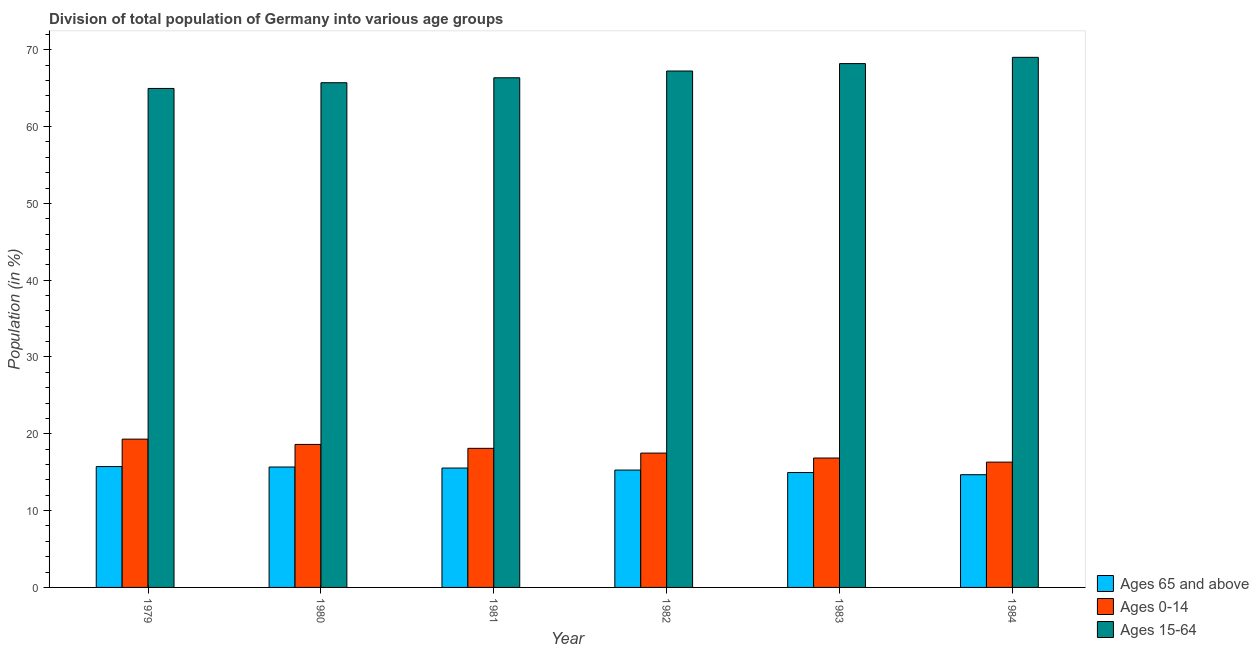Are the number of bars per tick equal to the number of legend labels?
Give a very brief answer. Yes. Are the number of bars on each tick of the X-axis equal?
Your answer should be compact. Yes. How many bars are there on the 6th tick from the right?
Provide a short and direct response. 3. What is the label of the 4th group of bars from the left?
Your answer should be compact. 1982. What is the percentage of population within the age-group 0-14 in 1982?
Make the answer very short. 17.49. Across all years, what is the maximum percentage of population within the age-group 15-64?
Provide a succinct answer. 69.01. Across all years, what is the minimum percentage of population within the age-group of 65 and above?
Your answer should be very brief. 14.67. In which year was the percentage of population within the age-group 15-64 minimum?
Your answer should be compact. 1979. What is the total percentage of population within the age-group 0-14 in the graph?
Provide a short and direct response. 106.68. What is the difference between the percentage of population within the age-group of 65 and above in 1981 and that in 1983?
Ensure brevity in your answer.  0.59. What is the difference between the percentage of population within the age-group 0-14 in 1982 and the percentage of population within the age-group of 65 and above in 1981?
Your response must be concise. -0.62. What is the average percentage of population within the age-group of 65 and above per year?
Your answer should be compact. 15.31. What is the ratio of the percentage of population within the age-group 15-64 in 1979 to that in 1982?
Offer a very short reply. 0.97. Is the difference between the percentage of population within the age-group 15-64 in 1981 and 1984 greater than the difference between the percentage of population within the age-group of 65 and above in 1981 and 1984?
Give a very brief answer. No. What is the difference between the highest and the second highest percentage of population within the age-group of 65 and above?
Keep it short and to the point. 0.06. What is the difference between the highest and the lowest percentage of population within the age-group 0-14?
Offer a very short reply. 2.99. In how many years, is the percentage of population within the age-group 15-64 greater than the average percentage of population within the age-group 15-64 taken over all years?
Ensure brevity in your answer.  3. Is the sum of the percentage of population within the age-group 0-14 in 1980 and 1982 greater than the maximum percentage of population within the age-group 15-64 across all years?
Keep it short and to the point. Yes. What does the 2nd bar from the left in 1980 represents?
Offer a very short reply. Ages 0-14. What does the 3rd bar from the right in 1983 represents?
Give a very brief answer. Ages 65 and above. Are all the bars in the graph horizontal?
Provide a short and direct response. No. How many years are there in the graph?
Offer a very short reply. 6. What is the difference between two consecutive major ticks on the Y-axis?
Offer a very short reply. 10. Are the values on the major ticks of Y-axis written in scientific E-notation?
Offer a very short reply. No. Does the graph contain grids?
Make the answer very short. No. How many legend labels are there?
Ensure brevity in your answer.  3. What is the title of the graph?
Give a very brief answer. Division of total population of Germany into various age groups
. Does "Transport equipments" appear as one of the legend labels in the graph?
Provide a short and direct response. No. What is the label or title of the X-axis?
Make the answer very short. Year. What is the Population (in %) of Ages 65 and above in 1979?
Give a very brief answer. 15.73. What is the Population (in %) in Ages 0-14 in 1979?
Your response must be concise. 19.31. What is the Population (in %) in Ages 15-64 in 1979?
Offer a terse response. 64.96. What is the Population (in %) in Ages 65 and above in 1980?
Offer a very short reply. 15.68. What is the Population (in %) of Ages 0-14 in 1980?
Make the answer very short. 18.62. What is the Population (in %) in Ages 15-64 in 1980?
Offer a terse response. 65.71. What is the Population (in %) in Ages 65 and above in 1981?
Make the answer very short. 15.54. What is the Population (in %) in Ages 0-14 in 1981?
Your response must be concise. 18.11. What is the Population (in %) in Ages 15-64 in 1981?
Offer a very short reply. 66.35. What is the Population (in %) in Ages 65 and above in 1982?
Offer a very short reply. 15.28. What is the Population (in %) of Ages 0-14 in 1982?
Offer a very short reply. 17.49. What is the Population (in %) in Ages 15-64 in 1982?
Offer a terse response. 67.23. What is the Population (in %) of Ages 65 and above in 1983?
Keep it short and to the point. 14.96. What is the Population (in %) in Ages 0-14 in 1983?
Your answer should be compact. 16.85. What is the Population (in %) in Ages 15-64 in 1983?
Give a very brief answer. 68.2. What is the Population (in %) of Ages 65 and above in 1984?
Make the answer very short. 14.67. What is the Population (in %) in Ages 0-14 in 1984?
Give a very brief answer. 16.31. What is the Population (in %) of Ages 15-64 in 1984?
Your answer should be very brief. 69.01. Across all years, what is the maximum Population (in %) of Ages 65 and above?
Give a very brief answer. 15.73. Across all years, what is the maximum Population (in %) in Ages 0-14?
Ensure brevity in your answer.  19.31. Across all years, what is the maximum Population (in %) in Ages 15-64?
Keep it short and to the point. 69.01. Across all years, what is the minimum Population (in %) of Ages 65 and above?
Give a very brief answer. 14.67. Across all years, what is the minimum Population (in %) in Ages 0-14?
Provide a short and direct response. 16.31. Across all years, what is the minimum Population (in %) of Ages 15-64?
Provide a succinct answer. 64.96. What is the total Population (in %) of Ages 65 and above in the graph?
Give a very brief answer. 91.86. What is the total Population (in %) of Ages 0-14 in the graph?
Keep it short and to the point. 106.68. What is the total Population (in %) of Ages 15-64 in the graph?
Provide a succinct answer. 401.46. What is the difference between the Population (in %) in Ages 65 and above in 1979 and that in 1980?
Offer a very short reply. 0.06. What is the difference between the Population (in %) in Ages 0-14 in 1979 and that in 1980?
Provide a succinct answer. 0.69. What is the difference between the Population (in %) of Ages 15-64 in 1979 and that in 1980?
Make the answer very short. -0.75. What is the difference between the Population (in %) in Ages 65 and above in 1979 and that in 1981?
Your response must be concise. 0.19. What is the difference between the Population (in %) in Ages 0-14 in 1979 and that in 1981?
Ensure brevity in your answer.  1.2. What is the difference between the Population (in %) of Ages 15-64 in 1979 and that in 1981?
Offer a terse response. -1.39. What is the difference between the Population (in %) of Ages 65 and above in 1979 and that in 1982?
Ensure brevity in your answer.  0.45. What is the difference between the Population (in %) of Ages 0-14 in 1979 and that in 1982?
Keep it short and to the point. 1.82. What is the difference between the Population (in %) in Ages 15-64 in 1979 and that in 1982?
Your response must be concise. -2.27. What is the difference between the Population (in %) of Ages 65 and above in 1979 and that in 1983?
Offer a terse response. 0.78. What is the difference between the Population (in %) of Ages 0-14 in 1979 and that in 1983?
Keep it short and to the point. 2.46. What is the difference between the Population (in %) in Ages 15-64 in 1979 and that in 1983?
Offer a terse response. -3.24. What is the difference between the Population (in %) in Ages 65 and above in 1979 and that in 1984?
Ensure brevity in your answer.  1.06. What is the difference between the Population (in %) in Ages 0-14 in 1979 and that in 1984?
Ensure brevity in your answer.  2.99. What is the difference between the Population (in %) in Ages 15-64 in 1979 and that in 1984?
Provide a short and direct response. -4.05. What is the difference between the Population (in %) in Ages 65 and above in 1980 and that in 1981?
Ensure brevity in your answer.  0.14. What is the difference between the Population (in %) of Ages 0-14 in 1980 and that in 1981?
Give a very brief answer. 0.51. What is the difference between the Population (in %) in Ages 15-64 in 1980 and that in 1981?
Provide a succinct answer. -0.64. What is the difference between the Population (in %) of Ages 65 and above in 1980 and that in 1982?
Provide a succinct answer. 0.4. What is the difference between the Population (in %) of Ages 0-14 in 1980 and that in 1982?
Make the answer very short. 1.13. What is the difference between the Population (in %) of Ages 15-64 in 1980 and that in 1982?
Give a very brief answer. -1.52. What is the difference between the Population (in %) in Ages 65 and above in 1980 and that in 1983?
Provide a short and direct response. 0.72. What is the difference between the Population (in %) of Ages 0-14 in 1980 and that in 1983?
Provide a short and direct response. 1.77. What is the difference between the Population (in %) of Ages 15-64 in 1980 and that in 1983?
Give a very brief answer. -2.49. What is the difference between the Population (in %) in Ages 0-14 in 1980 and that in 1984?
Give a very brief answer. 2.3. What is the difference between the Population (in %) in Ages 15-64 in 1980 and that in 1984?
Offer a very short reply. -3.31. What is the difference between the Population (in %) of Ages 65 and above in 1981 and that in 1982?
Ensure brevity in your answer.  0.26. What is the difference between the Population (in %) in Ages 0-14 in 1981 and that in 1982?
Offer a terse response. 0.62. What is the difference between the Population (in %) of Ages 15-64 in 1981 and that in 1982?
Make the answer very short. -0.88. What is the difference between the Population (in %) of Ages 65 and above in 1981 and that in 1983?
Provide a succinct answer. 0.59. What is the difference between the Population (in %) of Ages 0-14 in 1981 and that in 1983?
Your response must be concise. 1.26. What is the difference between the Population (in %) in Ages 15-64 in 1981 and that in 1983?
Your response must be concise. -1.85. What is the difference between the Population (in %) in Ages 65 and above in 1981 and that in 1984?
Your response must be concise. 0.87. What is the difference between the Population (in %) of Ages 0-14 in 1981 and that in 1984?
Provide a short and direct response. 1.79. What is the difference between the Population (in %) in Ages 15-64 in 1981 and that in 1984?
Provide a short and direct response. -2.66. What is the difference between the Population (in %) in Ages 65 and above in 1982 and that in 1983?
Ensure brevity in your answer.  0.32. What is the difference between the Population (in %) of Ages 0-14 in 1982 and that in 1983?
Provide a short and direct response. 0.64. What is the difference between the Population (in %) in Ages 15-64 in 1982 and that in 1983?
Make the answer very short. -0.97. What is the difference between the Population (in %) in Ages 65 and above in 1982 and that in 1984?
Offer a terse response. 0.6. What is the difference between the Population (in %) of Ages 0-14 in 1982 and that in 1984?
Ensure brevity in your answer.  1.18. What is the difference between the Population (in %) in Ages 15-64 in 1982 and that in 1984?
Offer a terse response. -1.78. What is the difference between the Population (in %) in Ages 65 and above in 1983 and that in 1984?
Provide a short and direct response. 0.28. What is the difference between the Population (in %) in Ages 0-14 in 1983 and that in 1984?
Offer a very short reply. 0.53. What is the difference between the Population (in %) in Ages 15-64 in 1983 and that in 1984?
Your answer should be very brief. -0.82. What is the difference between the Population (in %) in Ages 65 and above in 1979 and the Population (in %) in Ages 0-14 in 1980?
Give a very brief answer. -2.88. What is the difference between the Population (in %) in Ages 65 and above in 1979 and the Population (in %) in Ages 15-64 in 1980?
Your answer should be compact. -49.97. What is the difference between the Population (in %) in Ages 0-14 in 1979 and the Population (in %) in Ages 15-64 in 1980?
Give a very brief answer. -46.4. What is the difference between the Population (in %) of Ages 65 and above in 1979 and the Population (in %) of Ages 0-14 in 1981?
Ensure brevity in your answer.  -2.37. What is the difference between the Population (in %) in Ages 65 and above in 1979 and the Population (in %) in Ages 15-64 in 1981?
Your response must be concise. -50.62. What is the difference between the Population (in %) in Ages 0-14 in 1979 and the Population (in %) in Ages 15-64 in 1981?
Your answer should be compact. -47.04. What is the difference between the Population (in %) in Ages 65 and above in 1979 and the Population (in %) in Ages 0-14 in 1982?
Provide a short and direct response. -1.76. What is the difference between the Population (in %) of Ages 65 and above in 1979 and the Population (in %) of Ages 15-64 in 1982?
Offer a very short reply. -51.5. What is the difference between the Population (in %) of Ages 0-14 in 1979 and the Population (in %) of Ages 15-64 in 1982?
Keep it short and to the point. -47.93. What is the difference between the Population (in %) of Ages 65 and above in 1979 and the Population (in %) of Ages 0-14 in 1983?
Offer a terse response. -1.11. What is the difference between the Population (in %) in Ages 65 and above in 1979 and the Population (in %) in Ages 15-64 in 1983?
Keep it short and to the point. -52.46. What is the difference between the Population (in %) of Ages 0-14 in 1979 and the Population (in %) of Ages 15-64 in 1983?
Your response must be concise. -48.89. What is the difference between the Population (in %) in Ages 65 and above in 1979 and the Population (in %) in Ages 0-14 in 1984?
Provide a succinct answer. -0.58. What is the difference between the Population (in %) in Ages 65 and above in 1979 and the Population (in %) in Ages 15-64 in 1984?
Give a very brief answer. -53.28. What is the difference between the Population (in %) of Ages 0-14 in 1979 and the Population (in %) of Ages 15-64 in 1984?
Keep it short and to the point. -49.71. What is the difference between the Population (in %) of Ages 65 and above in 1980 and the Population (in %) of Ages 0-14 in 1981?
Keep it short and to the point. -2.43. What is the difference between the Population (in %) in Ages 65 and above in 1980 and the Population (in %) in Ages 15-64 in 1981?
Make the answer very short. -50.67. What is the difference between the Population (in %) in Ages 0-14 in 1980 and the Population (in %) in Ages 15-64 in 1981?
Offer a very short reply. -47.73. What is the difference between the Population (in %) in Ages 65 and above in 1980 and the Population (in %) in Ages 0-14 in 1982?
Give a very brief answer. -1.81. What is the difference between the Population (in %) of Ages 65 and above in 1980 and the Population (in %) of Ages 15-64 in 1982?
Offer a very short reply. -51.55. What is the difference between the Population (in %) of Ages 0-14 in 1980 and the Population (in %) of Ages 15-64 in 1982?
Offer a terse response. -48.61. What is the difference between the Population (in %) of Ages 65 and above in 1980 and the Population (in %) of Ages 0-14 in 1983?
Your answer should be very brief. -1.17. What is the difference between the Population (in %) in Ages 65 and above in 1980 and the Population (in %) in Ages 15-64 in 1983?
Keep it short and to the point. -52.52. What is the difference between the Population (in %) of Ages 0-14 in 1980 and the Population (in %) of Ages 15-64 in 1983?
Provide a short and direct response. -49.58. What is the difference between the Population (in %) in Ages 65 and above in 1980 and the Population (in %) in Ages 0-14 in 1984?
Your answer should be very brief. -0.64. What is the difference between the Population (in %) in Ages 65 and above in 1980 and the Population (in %) in Ages 15-64 in 1984?
Your response must be concise. -53.33. What is the difference between the Population (in %) of Ages 0-14 in 1980 and the Population (in %) of Ages 15-64 in 1984?
Ensure brevity in your answer.  -50.4. What is the difference between the Population (in %) of Ages 65 and above in 1981 and the Population (in %) of Ages 0-14 in 1982?
Ensure brevity in your answer.  -1.95. What is the difference between the Population (in %) of Ages 65 and above in 1981 and the Population (in %) of Ages 15-64 in 1982?
Give a very brief answer. -51.69. What is the difference between the Population (in %) in Ages 0-14 in 1981 and the Population (in %) in Ages 15-64 in 1982?
Offer a very short reply. -49.12. What is the difference between the Population (in %) of Ages 65 and above in 1981 and the Population (in %) of Ages 0-14 in 1983?
Your answer should be very brief. -1.31. What is the difference between the Population (in %) in Ages 65 and above in 1981 and the Population (in %) in Ages 15-64 in 1983?
Your response must be concise. -52.65. What is the difference between the Population (in %) of Ages 0-14 in 1981 and the Population (in %) of Ages 15-64 in 1983?
Provide a short and direct response. -50.09. What is the difference between the Population (in %) of Ages 65 and above in 1981 and the Population (in %) of Ages 0-14 in 1984?
Ensure brevity in your answer.  -0.77. What is the difference between the Population (in %) of Ages 65 and above in 1981 and the Population (in %) of Ages 15-64 in 1984?
Your response must be concise. -53.47. What is the difference between the Population (in %) in Ages 0-14 in 1981 and the Population (in %) in Ages 15-64 in 1984?
Offer a terse response. -50.9. What is the difference between the Population (in %) in Ages 65 and above in 1982 and the Population (in %) in Ages 0-14 in 1983?
Offer a terse response. -1.57. What is the difference between the Population (in %) of Ages 65 and above in 1982 and the Population (in %) of Ages 15-64 in 1983?
Provide a short and direct response. -52.92. What is the difference between the Population (in %) of Ages 0-14 in 1982 and the Population (in %) of Ages 15-64 in 1983?
Keep it short and to the point. -50.71. What is the difference between the Population (in %) in Ages 65 and above in 1982 and the Population (in %) in Ages 0-14 in 1984?
Your response must be concise. -1.03. What is the difference between the Population (in %) in Ages 65 and above in 1982 and the Population (in %) in Ages 15-64 in 1984?
Provide a short and direct response. -53.73. What is the difference between the Population (in %) of Ages 0-14 in 1982 and the Population (in %) of Ages 15-64 in 1984?
Give a very brief answer. -51.52. What is the difference between the Population (in %) in Ages 65 and above in 1983 and the Population (in %) in Ages 0-14 in 1984?
Offer a very short reply. -1.36. What is the difference between the Population (in %) of Ages 65 and above in 1983 and the Population (in %) of Ages 15-64 in 1984?
Provide a short and direct response. -54.05. What is the difference between the Population (in %) in Ages 0-14 in 1983 and the Population (in %) in Ages 15-64 in 1984?
Offer a very short reply. -52.16. What is the average Population (in %) in Ages 65 and above per year?
Provide a short and direct response. 15.31. What is the average Population (in %) of Ages 0-14 per year?
Ensure brevity in your answer.  17.78. What is the average Population (in %) of Ages 15-64 per year?
Provide a succinct answer. 66.91. In the year 1979, what is the difference between the Population (in %) in Ages 65 and above and Population (in %) in Ages 0-14?
Your response must be concise. -3.57. In the year 1979, what is the difference between the Population (in %) in Ages 65 and above and Population (in %) in Ages 15-64?
Your response must be concise. -49.23. In the year 1979, what is the difference between the Population (in %) of Ages 0-14 and Population (in %) of Ages 15-64?
Give a very brief answer. -45.66. In the year 1980, what is the difference between the Population (in %) of Ages 65 and above and Population (in %) of Ages 0-14?
Your response must be concise. -2.94. In the year 1980, what is the difference between the Population (in %) of Ages 65 and above and Population (in %) of Ages 15-64?
Give a very brief answer. -50.03. In the year 1980, what is the difference between the Population (in %) of Ages 0-14 and Population (in %) of Ages 15-64?
Give a very brief answer. -47.09. In the year 1981, what is the difference between the Population (in %) of Ages 65 and above and Population (in %) of Ages 0-14?
Keep it short and to the point. -2.57. In the year 1981, what is the difference between the Population (in %) in Ages 65 and above and Population (in %) in Ages 15-64?
Ensure brevity in your answer.  -50.81. In the year 1981, what is the difference between the Population (in %) of Ages 0-14 and Population (in %) of Ages 15-64?
Ensure brevity in your answer.  -48.24. In the year 1982, what is the difference between the Population (in %) of Ages 65 and above and Population (in %) of Ages 0-14?
Your answer should be very brief. -2.21. In the year 1982, what is the difference between the Population (in %) in Ages 65 and above and Population (in %) in Ages 15-64?
Give a very brief answer. -51.95. In the year 1982, what is the difference between the Population (in %) in Ages 0-14 and Population (in %) in Ages 15-64?
Your answer should be very brief. -49.74. In the year 1983, what is the difference between the Population (in %) of Ages 65 and above and Population (in %) of Ages 0-14?
Offer a terse response. -1.89. In the year 1983, what is the difference between the Population (in %) of Ages 65 and above and Population (in %) of Ages 15-64?
Make the answer very short. -53.24. In the year 1983, what is the difference between the Population (in %) of Ages 0-14 and Population (in %) of Ages 15-64?
Offer a terse response. -51.35. In the year 1984, what is the difference between the Population (in %) of Ages 65 and above and Population (in %) of Ages 0-14?
Provide a succinct answer. -1.64. In the year 1984, what is the difference between the Population (in %) in Ages 65 and above and Population (in %) in Ages 15-64?
Offer a terse response. -54.34. In the year 1984, what is the difference between the Population (in %) of Ages 0-14 and Population (in %) of Ages 15-64?
Offer a very short reply. -52.7. What is the ratio of the Population (in %) in Ages 65 and above in 1979 to that in 1980?
Provide a succinct answer. 1. What is the ratio of the Population (in %) in Ages 15-64 in 1979 to that in 1980?
Offer a very short reply. 0.99. What is the ratio of the Population (in %) in Ages 65 and above in 1979 to that in 1981?
Provide a short and direct response. 1.01. What is the ratio of the Population (in %) of Ages 0-14 in 1979 to that in 1981?
Offer a very short reply. 1.07. What is the ratio of the Population (in %) of Ages 15-64 in 1979 to that in 1981?
Keep it short and to the point. 0.98. What is the ratio of the Population (in %) of Ages 65 and above in 1979 to that in 1982?
Offer a very short reply. 1.03. What is the ratio of the Population (in %) in Ages 0-14 in 1979 to that in 1982?
Offer a terse response. 1.1. What is the ratio of the Population (in %) in Ages 15-64 in 1979 to that in 1982?
Your answer should be compact. 0.97. What is the ratio of the Population (in %) in Ages 65 and above in 1979 to that in 1983?
Your answer should be compact. 1.05. What is the ratio of the Population (in %) in Ages 0-14 in 1979 to that in 1983?
Make the answer very short. 1.15. What is the ratio of the Population (in %) of Ages 15-64 in 1979 to that in 1983?
Your response must be concise. 0.95. What is the ratio of the Population (in %) in Ages 65 and above in 1979 to that in 1984?
Your answer should be very brief. 1.07. What is the ratio of the Population (in %) of Ages 0-14 in 1979 to that in 1984?
Give a very brief answer. 1.18. What is the ratio of the Population (in %) of Ages 15-64 in 1979 to that in 1984?
Ensure brevity in your answer.  0.94. What is the ratio of the Population (in %) in Ages 65 and above in 1980 to that in 1981?
Keep it short and to the point. 1.01. What is the ratio of the Population (in %) of Ages 0-14 in 1980 to that in 1981?
Provide a succinct answer. 1.03. What is the ratio of the Population (in %) of Ages 15-64 in 1980 to that in 1981?
Offer a terse response. 0.99. What is the ratio of the Population (in %) of Ages 65 and above in 1980 to that in 1982?
Provide a short and direct response. 1.03. What is the ratio of the Population (in %) in Ages 0-14 in 1980 to that in 1982?
Make the answer very short. 1.06. What is the ratio of the Population (in %) of Ages 15-64 in 1980 to that in 1982?
Your response must be concise. 0.98. What is the ratio of the Population (in %) of Ages 65 and above in 1980 to that in 1983?
Your answer should be compact. 1.05. What is the ratio of the Population (in %) in Ages 0-14 in 1980 to that in 1983?
Offer a terse response. 1.1. What is the ratio of the Population (in %) in Ages 15-64 in 1980 to that in 1983?
Your response must be concise. 0.96. What is the ratio of the Population (in %) of Ages 65 and above in 1980 to that in 1984?
Your answer should be compact. 1.07. What is the ratio of the Population (in %) in Ages 0-14 in 1980 to that in 1984?
Keep it short and to the point. 1.14. What is the ratio of the Population (in %) of Ages 15-64 in 1980 to that in 1984?
Provide a short and direct response. 0.95. What is the ratio of the Population (in %) in Ages 65 and above in 1981 to that in 1982?
Keep it short and to the point. 1.02. What is the ratio of the Population (in %) in Ages 0-14 in 1981 to that in 1982?
Ensure brevity in your answer.  1.04. What is the ratio of the Population (in %) of Ages 15-64 in 1981 to that in 1982?
Your answer should be very brief. 0.99. What is the ratio of the Population (in %) of Ages 65 and above in 1981 to that in 1983?
Keep it short and to the point. 1.04. What is the ratio of the Population (in %) in Ages 0-14 in 1981 to that in 1983?
Your answer should be very brief. 1.07. What is the ratio of the Population (in %) of Ages 15-64 in 1981 to that in 1983?
Give a very brief answer. 0.97. What is the ratio of the Population (in %) in Ages 65 and above in 1981 to that in 1984?
Your answer should be very brief. 1.06. What is the ratio of the Population (in %) in Ages 0-14 in 1981 to that in 1984?
Make the answer very short. 1.11. What is the ratio of the Population (in %) in Ages 15-64 in 1981 to that in 1984?
Your response must be concise. 0.96. What is the ratio of the Population (in %) in Ages 65 and above in 1982 to that in 1983?
Ensure brevity in your answer.  1.02. What is the ratio of the Population (in %) in Ages 0-14 in 1982 to that in 1983?
Keep it short and to the point. 1.04. What is the ratio of the Population (in %) of Ages 15-64 in 1982 to that in 1983?
Provide a short and direct response. 0.99. What is the ratio of the Population (in %) of Ages 65 and above in 1982 to that in 1984?
Offer a very short reply. 1.04. What is the ratio of the Population (in %) of Ages 0-14 in 1982 to that in 1984?
Ensure brevity in your answer.  1.07. What is the ratio of the Population (in %) of Ages 15-64 in 1982 to that in 1984?
Offer a terse response. 0.97. What is the ratio of the Population (in %) of Ages 65 and above in 1983 to that in 1984?
Give a very brief answer. 1.02. What is the ratio of the Population (in %) in Ages 0-14 in 1983 to that in 1984?
Ensure brevity in your answer.  1.03. What is the difference between the highest and the second highest Population (in %) of Ages 65 and above?
Offer a terse response. 0.06. What is the difference between the highest and the second highest Population (in %) in Ages 0-14?
Provide a short and direct response. 0.69. What is the difference between the highest and the second highest Population (in %) in Ages 15-64?
Offer a terse response. 0.82. What is the difference between the highest and the lowest Population (in %) in Ages 65 and above?
Provide a succinct answer. 1.06. What is the difference between the highest and the lowest Population (in %) of Ages 0-14?
Provide a succinct answer. 2.99. What is the difference between the highest and the lowest Population (in %) in Ages 15-64?
Provide a succinct answer. 4.05. 